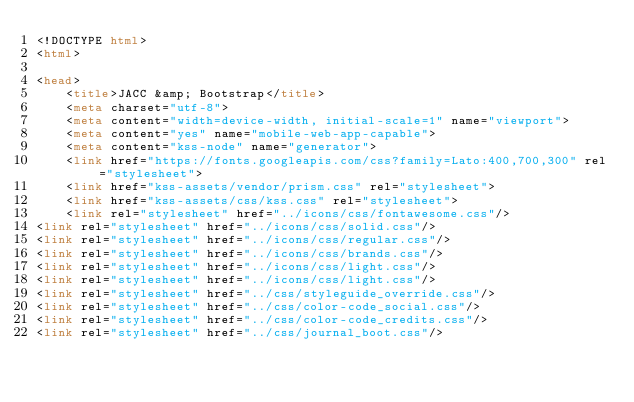<code> <loc_0><loc_0><loc_500><loc_500><_HTML_><!DOCTYPE html>
<html>

<head>
    <title>JACC &amp; Bootstrap</title>
    <meta charset="utf-8">
    <meta content="width=device-width, initial-scale=1" name="viewport">
    <meta content="yes" name="mobile-web-app-capable">
    <meta content="kss-node" name="generator">
    <link href="https://fonts.googleapis.com/css?family=Lato:400,700,300" rel="stylesheet">
    <link href="kss-assets/vendor/prism.css" rel="stylesheet">
    <link href="kss-assets/css/kss.css" rel="stylesheet">
    <link rel="stylesheet" href="../icons/css/fontawesome.css"/>
<link rel="stylesheet" href="../icons/css/solid.css"/>
<link rel="stylesheet" href="../icons/css/regular.css"/>
<link rel="stylesheet" href="../icons/css/brands.css"/>
<link rel="stylesheet" href="../icons/css/light.css"/>
<link rel="stylesheet" href="../icons/css/light.css"/>
<link rel="stylesheet" href="../css/styleguide_override.css"/>
<link rel="stylesheet" href="../css/color-code_social.css"/>
<link rel="stylesheet" href="../css/color-code_credits.css"/>
<link rel="stylesheet" href="../css/journal_boot.css"/></code> 